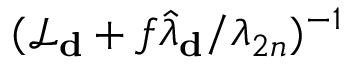Convert formula to latex. <formula><loc_0><loc_0><loc_500><loc_500>( \mathcal { L } _ { d } + f \hat { \lambda } _ { d } / \lambda _ { 2 n } ) ^ { - 1 }</formula> 